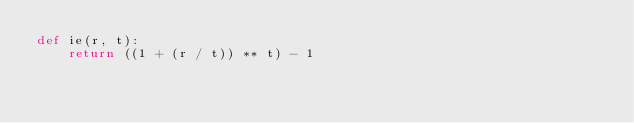Convert code to text. <code><loc_0><loc_0><loc_500><loc_500><_Python_>def ie(r, t):
    return ((1 + (r / t)) ** t) - 1
</code> 